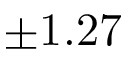Convert formula to latex. <formula><loc_0><loc_0><loc_500><loc_500>\pm 1 . 2 7</formula> 